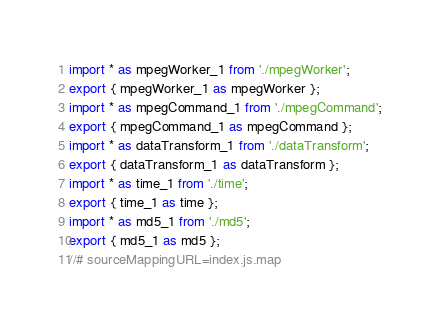<code> <loc_0><loc_0><loc_500><loc_500><_JavaScript_>import * as mpegWorker_1 from './mpegWorker';
export { mpegWorker_1 as mpegWorker };
import * as mpegCommand_1 from './mpegCommand';
export { mpegCommand_1 as mpegCommand };
import * as dataTransform_1 from './dataTransform';
export { dataTransform_1 as dataTransform };
import * as time_1 from './time';
export { time_1 as time };
import * as md5_1 from './md5';
export { md5_1 as md5 };
//# sourceMappingURL=index.js.map</code> 